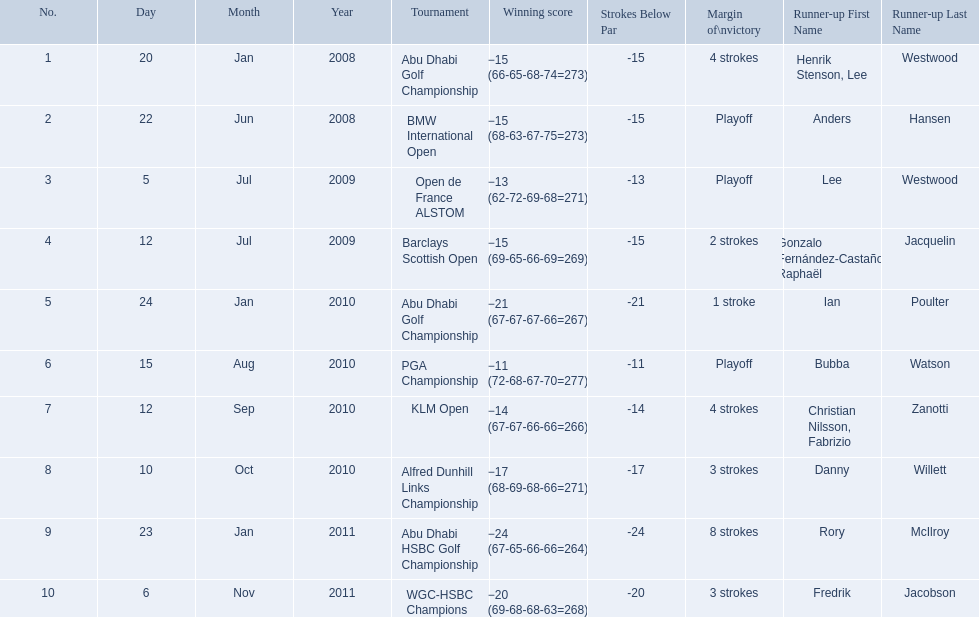What were all of the tournaments martin played in? Abu Dhabi Golf Championship, BMW International Open, Open de France ALSTOM, Barclays Scottish Open, Abu Dhabi Golf Championship, PGA Championship, KLM Open, Alfred Dunhill Links Championship, Abu Dhabi HSBC Golf Championship, WGC-HSBC Champions. And how many strokes did he score? −15 (66-65-68-74=273), −15 (68-63-67-75=273), −13 (62-72-69-68=271), −15 (69-65-66-69=269), −21 (67-67-67-66=267), −11 (72-68-67-70=277), −14 (67-67-66-66=266), −17 (68-69-68-66=271), −24 (67-65-66-66=264), −20 (69-68-68-63=268). What about during barclays and klm? −15 (69-65-66-69=269), −14 (67-67-66-66=266). How many more were scored in klm? 2 strokes. 